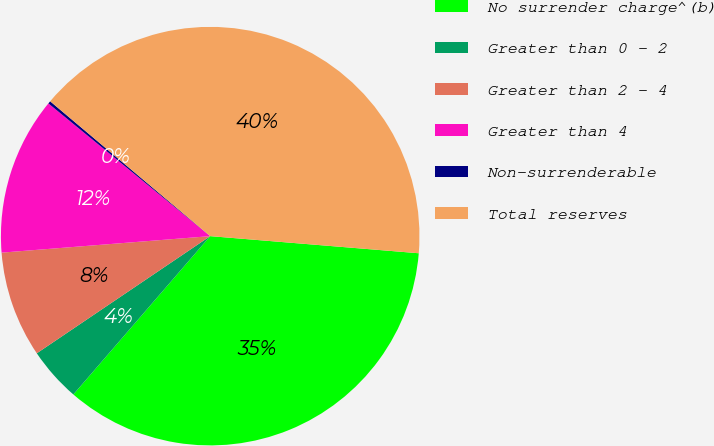<chart> <loc_0><loc_0><loc_500><loc_500><pie_chart><fcel>No surrender charge^(b)<fcel>Greater than 0 - 2<fcel>Greater than 2 - 4<fcel>Greater than 4<fcel>Non-surrenderable<fcel>Total reserves<nl><fcel>35.04%<fcel>4.2%<fcel>8.2%<fcel>12.19%<fcel>0.21%<fcel>40.16%<nl></chart> 